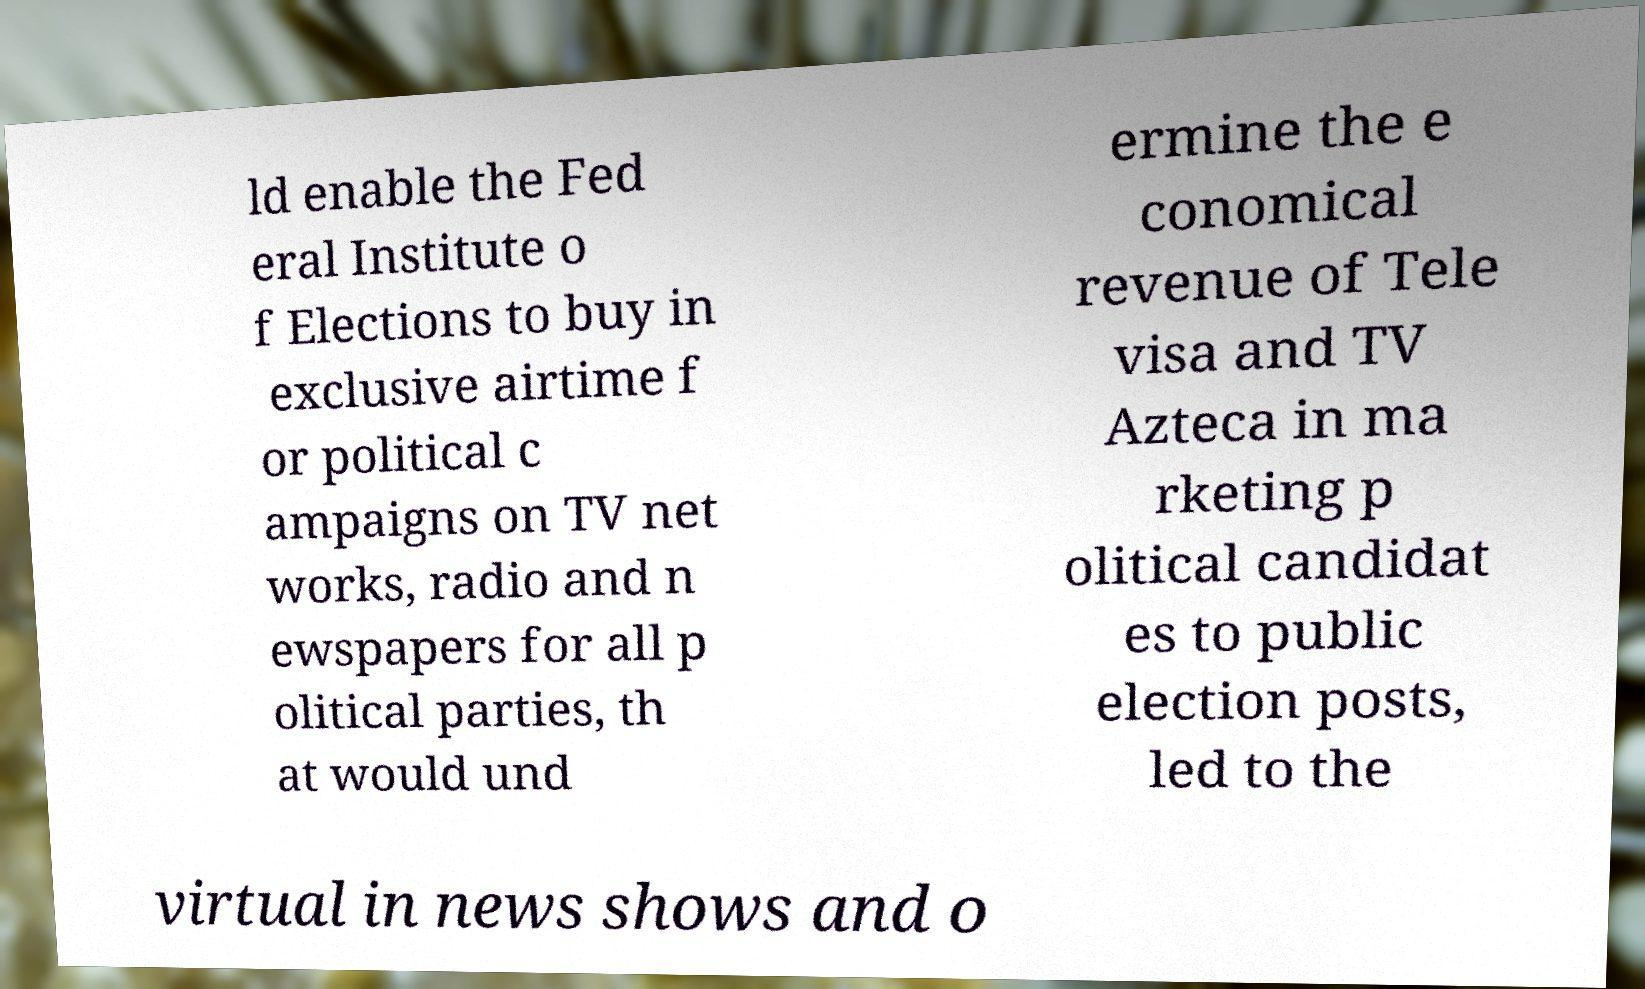For documentation purposes, I need the text within this image transcribed. Could you provide that? ld enable the Fed eral Institute o f Elections to buy in exclusive airtime f or political c ampaigns on TV net works, radio and n ewspapers for all p olitical parties, th at would und ermine the e conomical revenue of Tele visa and TV Azteca in ma rketing p olitical candidat es to public election posts, led to the virtual in news shows and o 